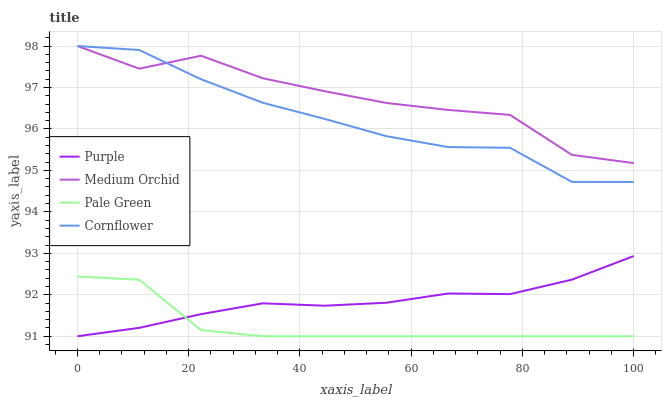Does Pale Green have the minimum area under the curve?
Answer yes or no. Yes. Does Medium Orchid have the maximum area under the curve?
Answer yes or no. Yes. Does Medium Orchid have the minimum area under the curve?
Answer yes or no. No. Does Pale Green have the maximum area under the curve?
Answer yes or no. No. Is Purple the smoothest?
Answer yes or no. Yes. Is Medium Orchid the roughest?
Answer yes or no. Yes. Is Pale Green the smoothest?
Answer yes or no. No. Is Pale Green the roughest?
Answer yes or no. No. Does Purple have the lowest value?
Answer yes or no. Yes. Does Medium Orchid have the lowest value?
Answer yes or no. No. Does Cornflower have the highest value?
Answer yes or no. Yes. Does Pale Green have the highest value?
Answer yes or no. No. Is Pale Green less than Cornflower?
Answer yes or no. Yes. Is Cornflower greater than Purple?
Answer yes or no. Yes. Does Cornflower intersect Medium Orchid?
Answer yes or no. Yes. Is Cornflower less than Medium Orchid?
Answer yes or no. No. Is Cornflower greater than Medium Orchid?
Answer yes or no. No. Does Pale Green intersect Cornflower?
Answer yes or no. No. 